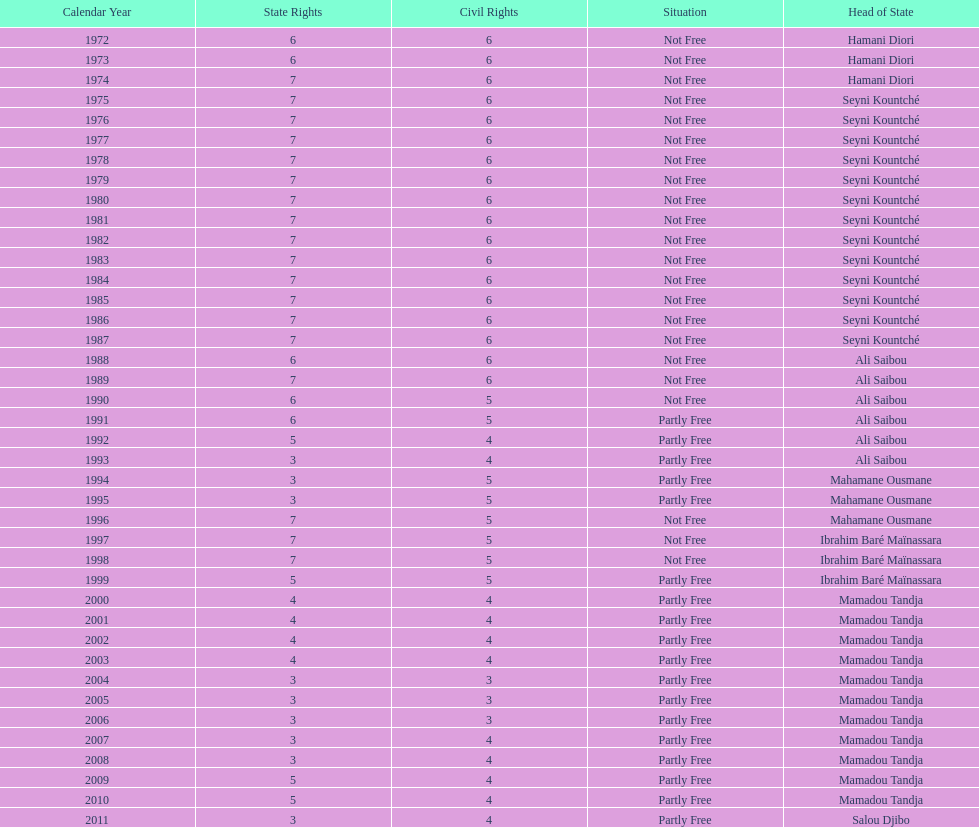How many years was ali saibou president? 6. 